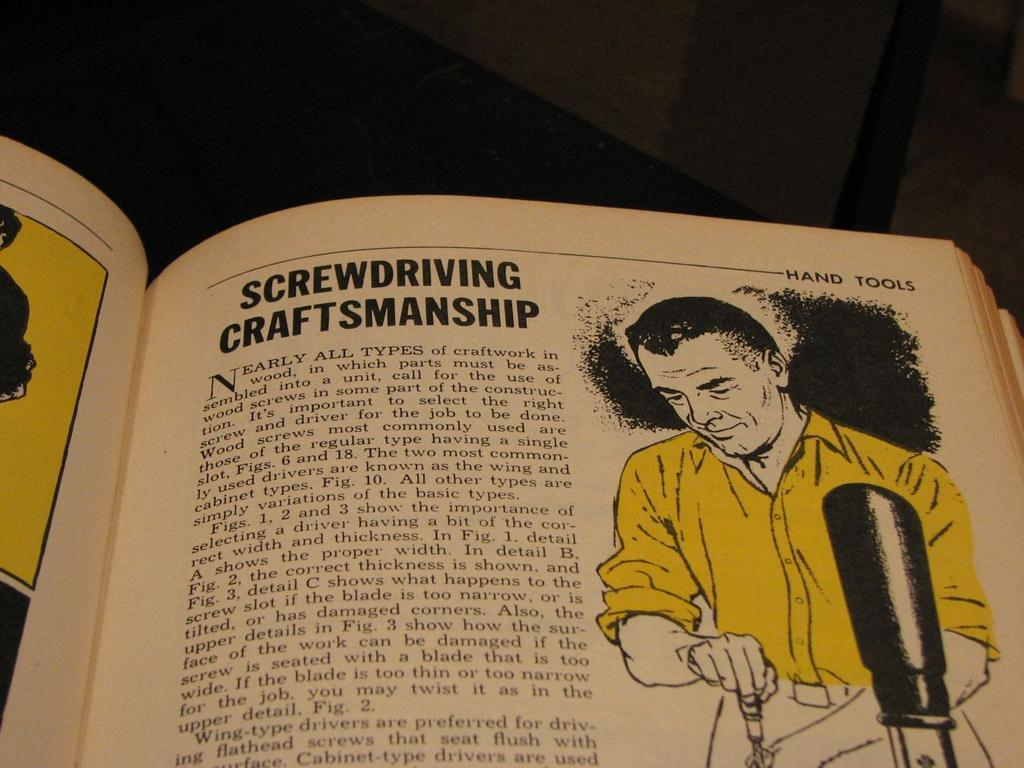<image>
Present a compact description of the photo's key features. A chapter from an older book titled Screwdriving craftsmanship 